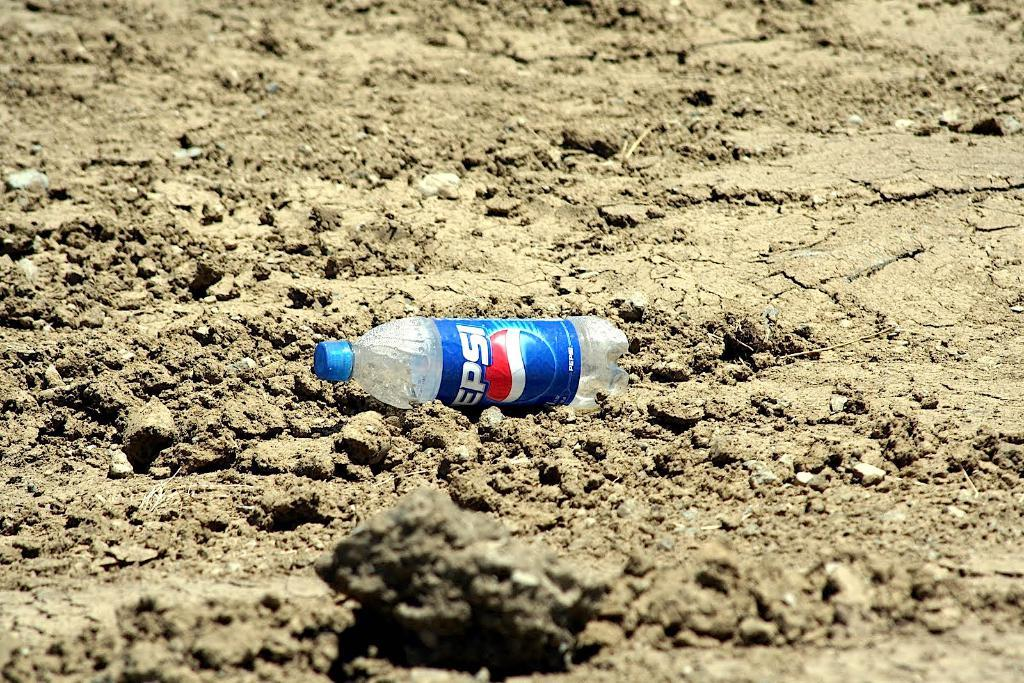<image>
Write a terse but informative summary of the picture. An empty Pepsi drink bottle that is on the ground. 